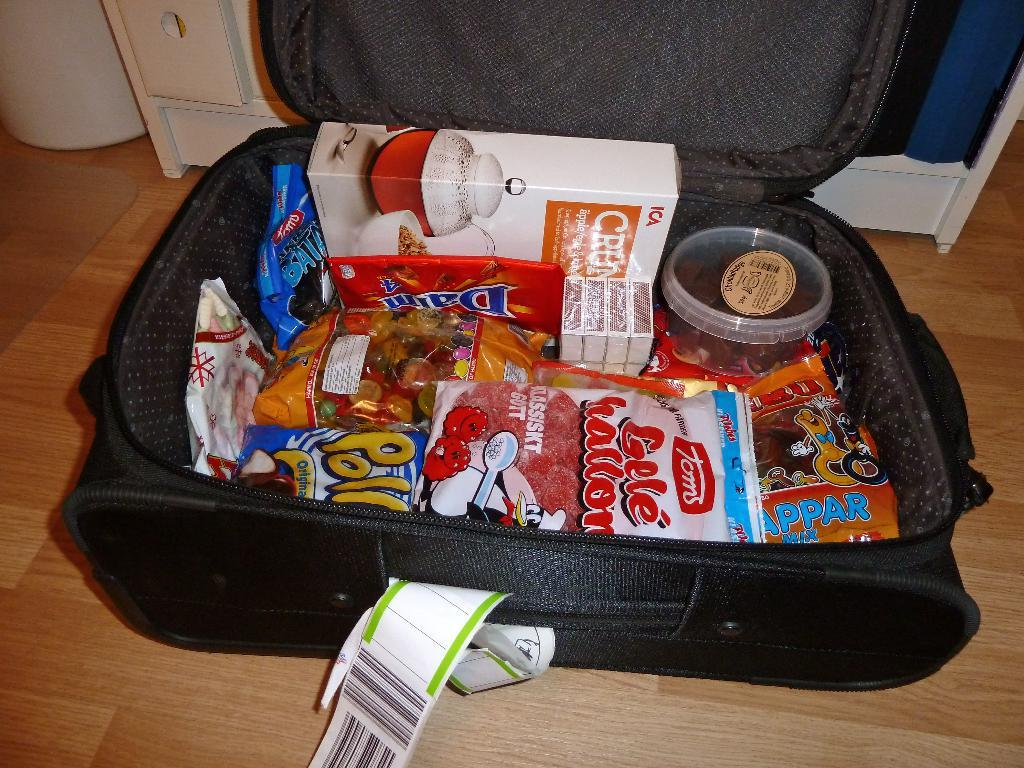What object is present on the floor in the image? There is a bag on the floor in the image. What is inside the bag? The bag contains a box, a cover, and other things. Can you describe the contents of the bag in more detail? The bag contains a box, a cover, and other things, but the specific contents of the other things are not mentioned in the facts. What type of pleasure can be seen in the girl's face in the image? There is no girl present in the image, and therefore no facial expression to describe. 